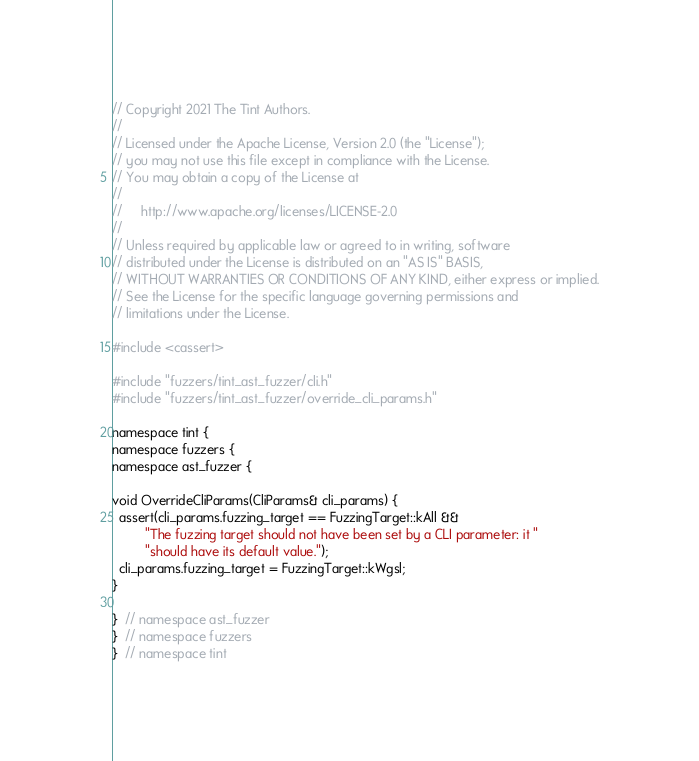Convert code to text. <code><loc_0><loc_0><loc_500><loc_500><_C++_>// Copyright 2021 The Tint Authors.
//
// Licensed under the Apache License, Version 2.0 (the "License");
// you may not use this file except in compliance with the License.
// You may obtain a copy of the License at
//
//     http://www.apache.org/licenses/LICENSE-2.0
//
// Unless required by applicable law or agreed to in writing, software
// distributed under the License is distributed on an "AS IS" BASIS,
// WITHOUT WARRANTIES OR CONDITIONS OF ANY KIND, either express or implied.
// See the License for the specific language governing permissions and
// limitations under the License.

#include <cassert>

#include "fuzzers/tint_ast_fuzzer/cli.h"
#include "fuzzers/tint_ast_fuzzer/override_cli_params.h"

namespace tint {
namespace fuzzers {
namespace ast_fuzzer {

void OverrideCliParams(CliParams& cli_params) {
  assert(cli_params.fuzzing_target == FuzzingTarget::kAll &&
         "The fuzzing target should not have been set by a CLI parameter: it "
         "should have its default value.");
  cli_params.fuzzing_target = FuzzingTarget::kWgsl;
}

}  // namespace ast_fuzzer
}  // namespace fuzzers
}  // namespace tint
</code> 